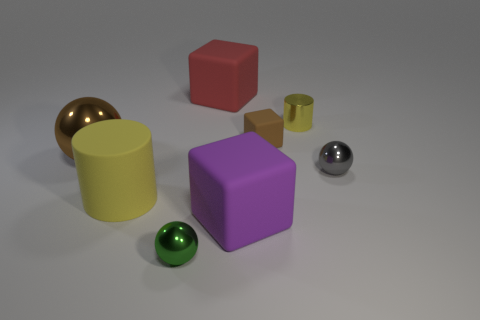Is the number of yellow cylinders on the left side of the large brown shiny object less than the number of small gray metal spheres in front of the purple cube?
Provide a succinct answer. No. Is the number of cubes behind the brown metal thing greater than the number of yellow things that are left of the small matte cube?
Your answer should be very brief. Yes. Is the shape of the big yellow matte object the same as the small yellow thing?
Your answer should be very brief. Yes. There is a purple rubber cube; is its size the same as the yellow object behind the brown metallic ball?
Your answer should be compact. No. There is a yellow object that is in front of the metal ball that is right of the metal sphere in front of the gray metallic thing; what is its size?
Your answer should be very brief. Large. How many things are either cylinders right of the tiny green metal object or small yellow metal things?
Provide a succinct answer. 1. How many large blocks are to the left of the large cube that is in front of the big red cube?
Keep it short and to the point. 1. Are there more small metal spheres that are to the right of the small metallic cylinder than small purple cylinders?
Give a very brief answer. Yes. There is a matte object that is left of the purple thing and in front of the yellow metallic cylinder; how big is it?
Your answer should be compact. Large. What shape is the metal object that is both in front of the yellow metallic object and on the right side of the large red rubber object?
Offer a very short reply. Sphere. 